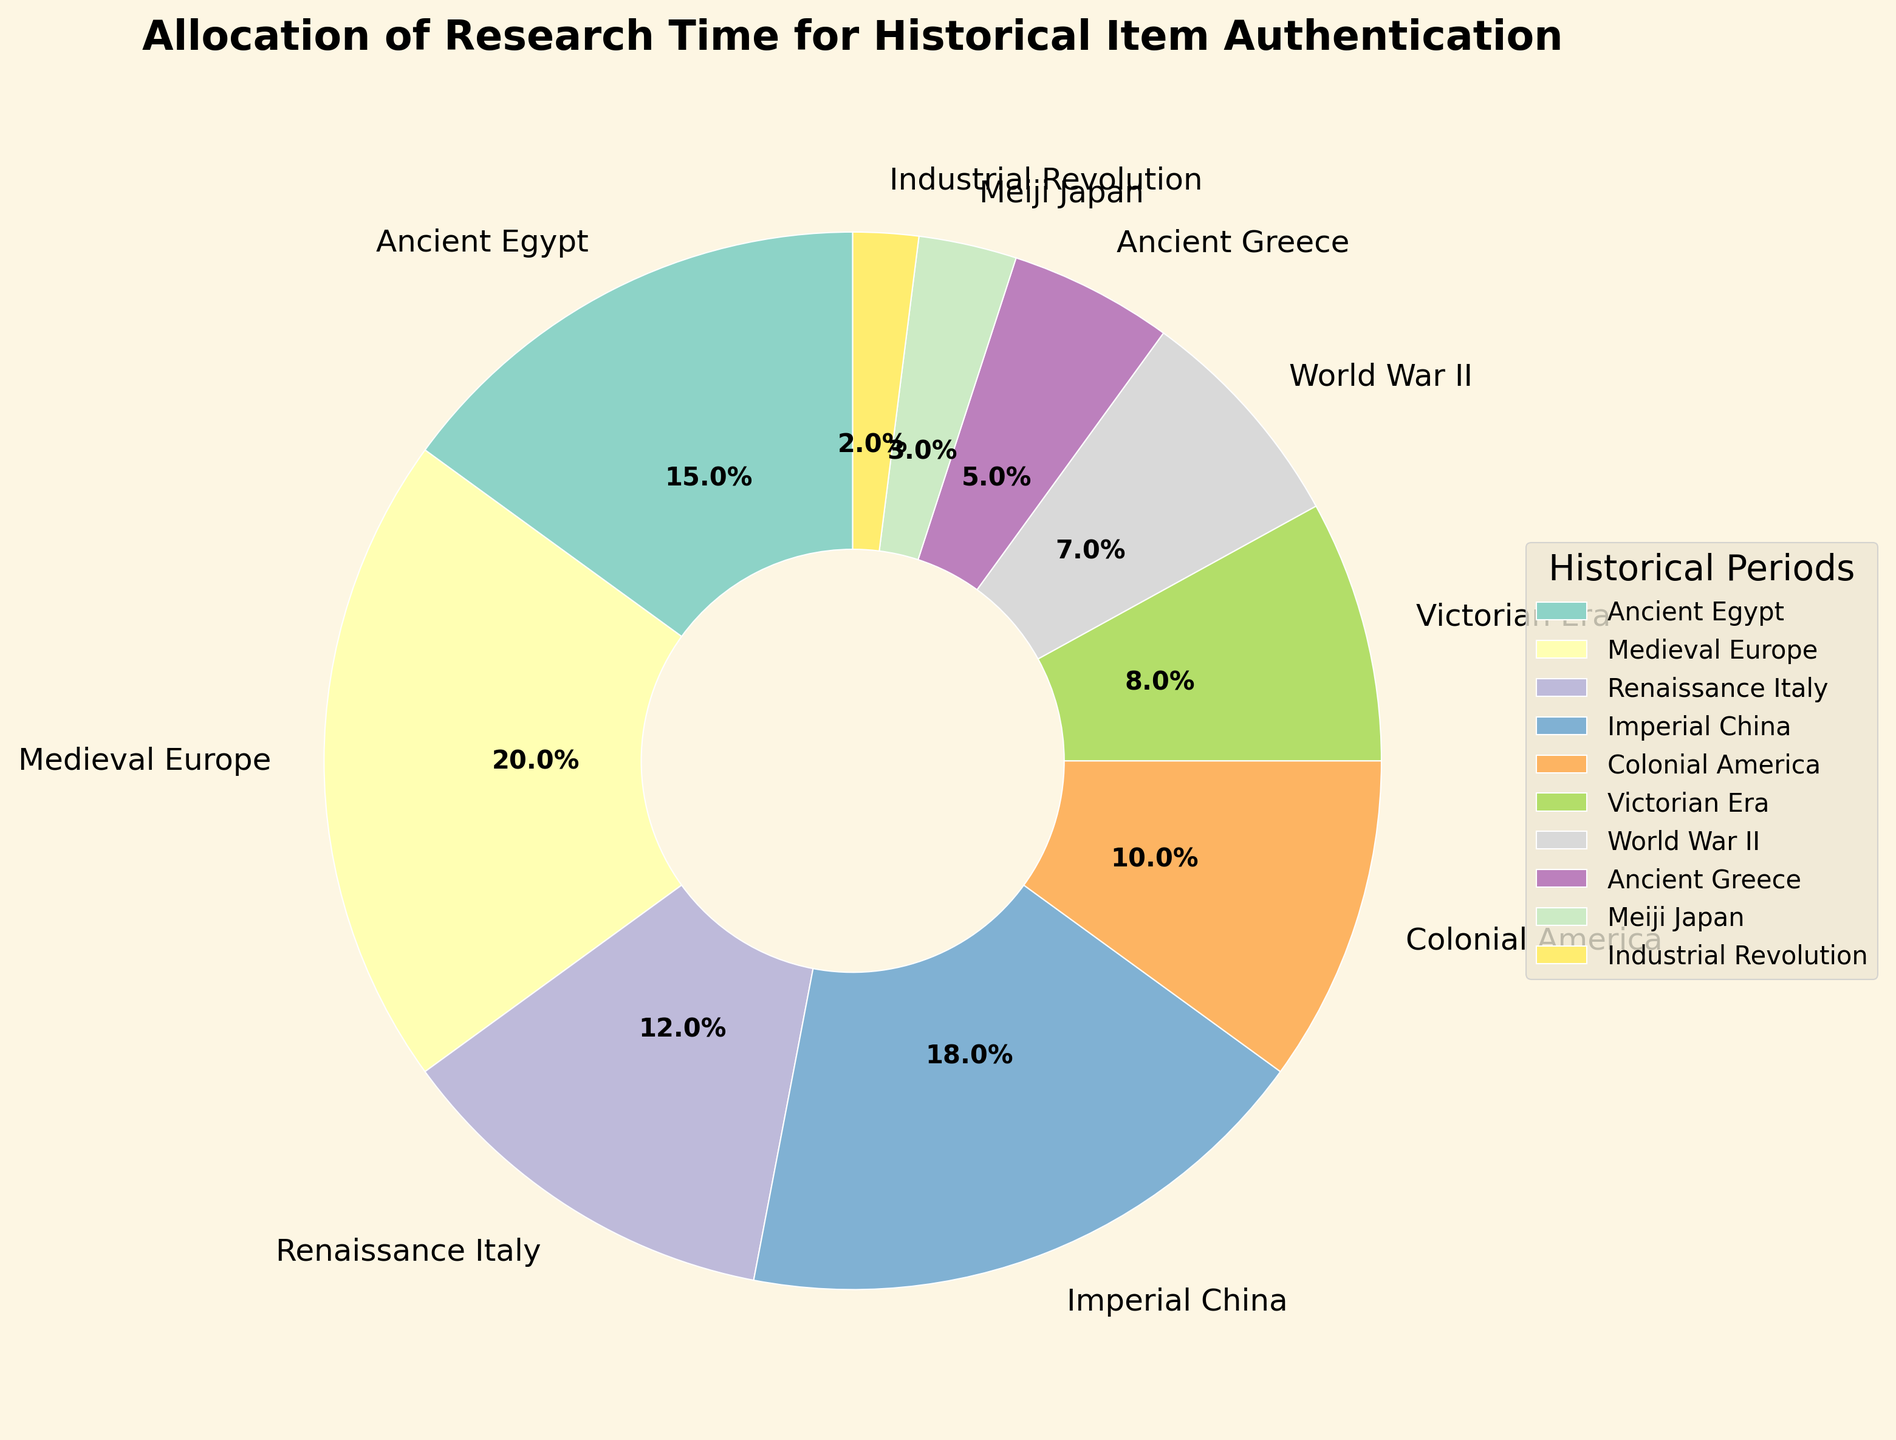What historical period requires the highest percentage of research time? The figure shows the allocation of research time percentages for various historical periods. By looking at the pie chart, the segment with the largest portion corresponds to Medieval Europe.
Answer: Medieval Europe Which two historical periods together make up 30% of the research time? Adding the research times of each period in the figure, Medieval Europe (20%) and Ancient Egypt (15%), sums up to 35%, the closest usable addition without exceeding over 30% involves the combination of Imperial China (18%) and Colonial America (10%), which add up to 28%.
Answer: Imperial China and Colonial America How does the allocation of research time for the Industrial Revolution compare to that for the Renaissance Italy? By comparing the respective pie chart segments for the Industrial Revolution and Renaissance Italy, we can observe that Renaissance Italy has a significantly larger portion (12%) compared to the Industrial Revolution (2%).
Answer: Renaissance Italy is greater What is the combined research time percentage for the World War II, Ancient Greece, and Meiji Japan periods? We need to sum the percentages for these three periods. World War II has 7%, Ancient Greece has 5%, and Meiji Japan has 3%. Adding them together, 7% + 5% + 3% equals 15%.
Answer: 15% Which periods require less than 10% of the research time each? By examining the pie chart and noting the percentages, the periods with less than 10% are Victorian Era (8%), World War II (7%), Ancient Greece (5%), Meiji Japan (3%), and Industrial Revolution (2%).
Answer: Victorian Era, World War II, Ancient Greece, Meiji Japan, Industrial Revolution 